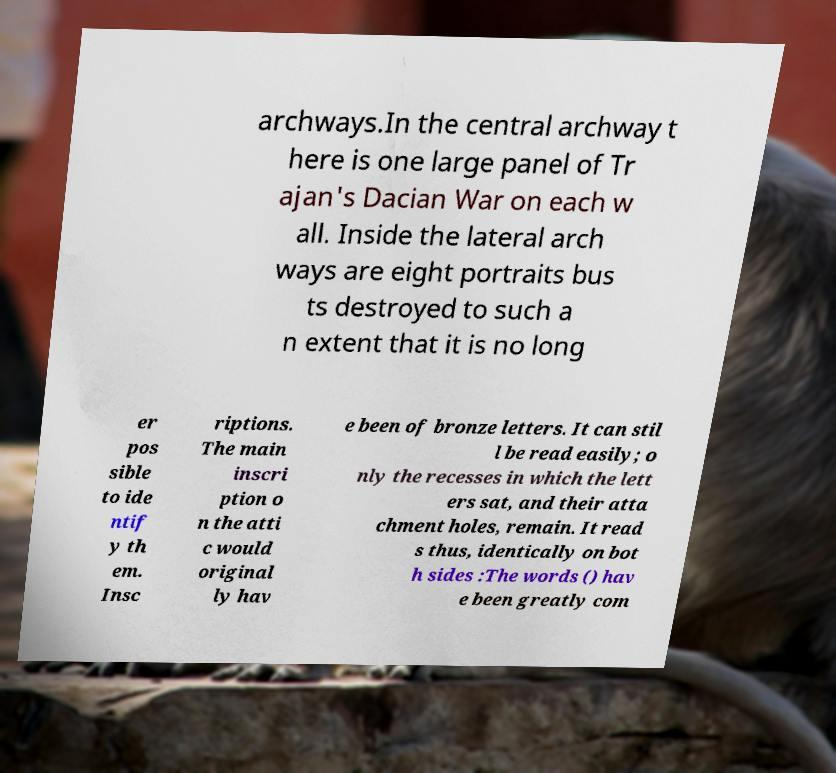Please identify and transcribe the text found in this image. archways.In the central archway t here is one large panel of Tr ajan's Dacian War on each w all. Inside the lateral arch ways are eight portraits bus ts destroyed to such a n extent that it is no long er pos sible to ide ntif y th em. Insc riptions. The main inscri ption o n the atti c would original ly hav e been of bronze letters. It can stil l be read easily; o nly the recesses in which the lett ers sat, and their atta chment holes, remain. It read s thus, identically on bot h sides :The words () hav e been greatly com 